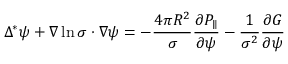Convert formula to latex. <formula><loc_0><loc_0><loc_500><loc_500>\Delta ^ { * } \psi + \nabla \ln \sigma \cdot \nabla \psi = - \frac { 4 \pi R ^ { 2 } } { \sigma } \frac { \partial P _ { \| } } { \partial \psi } - \frac { 1 } { \sigma ^ { 2 } } \frac { \partial G } { \partial \psi }</formula> 